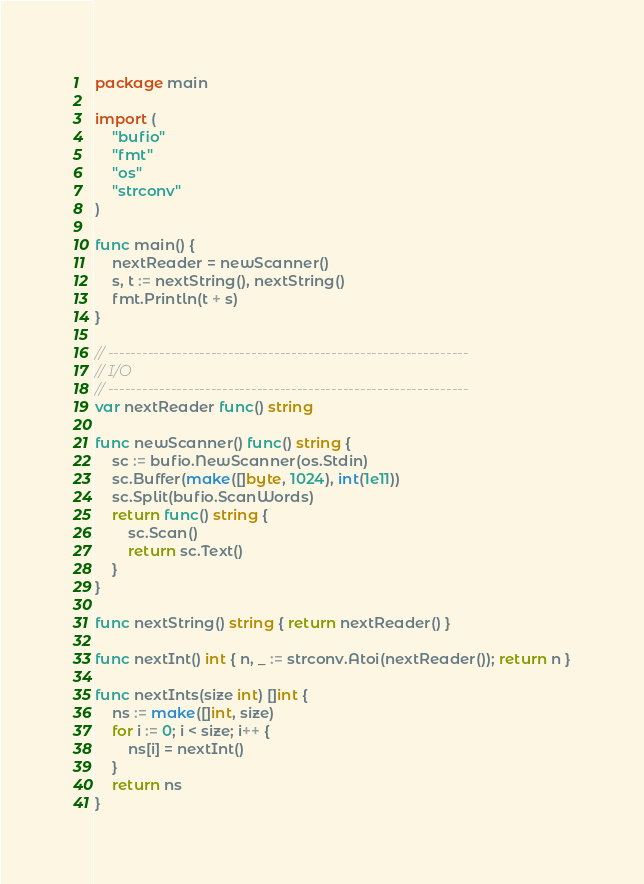<code> <loc_0><loc_0><loc_500><loc_500><_Go_>package main

import (
	"bufio"
	"fmt"
	"os"
	"strconv"
)

func main() {
	nextReader = newScanner()
	s, t := nextString(), nextString()
	fmt.Println(t + s)
}

// ---------------------------------------------------------------
// I/O
// ---------------------------------------------------------------
var nextReader func() string

func newScanner() func() string {
	sc := bufio.NewScanner(os.Stdin)
	sc.Buffer(make([]byte, 1024), int(1e11))
	sc.Split(bufio.ScanWords)
	return func() string {
		sc.Scan()
		return sc.Text()
	}
}

func nextString() string { return nextReader() }

func nextInt() int { n, _ := strconv.Atoi(nextReader()); return n }

func nextInts(size int) []int {
	ns := make([]int, size)
	for i := 0; i < size; i++ {
		ns[i] = nextInt()
	}
	return ns
}
</code> 